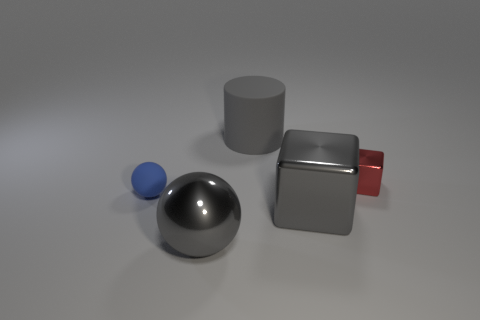Add 2 tiny red blocks. How many objects exist? 7 Subtract all balls. How many objects are left? 3 Subtract all cyan matte things. Subtract all rubber spheres. How many objects are left? 4 Add 4 small blue rubber spheres. How many small blue rubber spheres are left? 5 Add 4 gray spheres. How many gray spheres exist? 5 Subtract 0 green spheres. How many objects are left? 5 